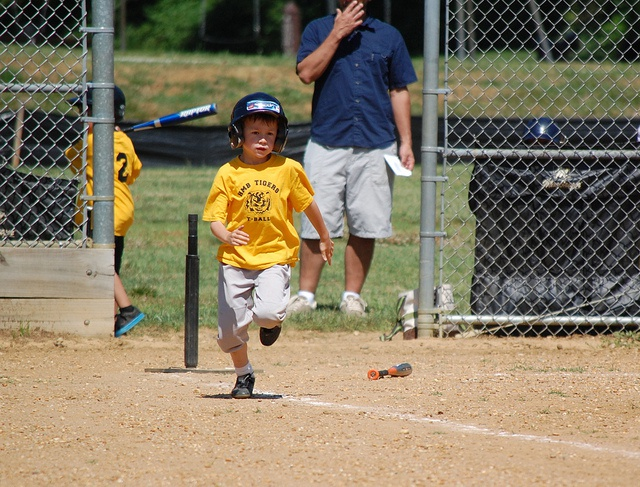Describe the objects in this image and their specific colors. I can see people in black, navy, lightgray, and darkgray tones, people in black, gold, brown, orange, and lightgray tones, people in black, orange, olive, and gray tones, baseball bat in black, lightgray, navy, and blue tones, and baseball bat in black, gray, brown, and red tones in this image. 